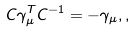Convert formula to latex. <formula><loc_0><loc_0><loc_500><loc_500>C \gamma _ { \mu } ^ { T } C ^ { - 1 } = - \gamma _ { \mu } , ,</formula> 